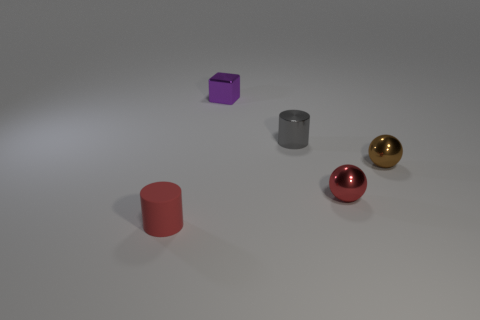Add 1 small gray shiny cylinders. How many objects exist? 6 Subtract all gray cylinders. How many cylinders are left? 1 Subtract all cylinders. How many objects are left? 3 Subtract 0 yellow balls. How many objects are left? 5 Subtract 2 spheres. How many spheres are left? 0 Subtract all brown spheres. Subtract all red blocks. How many spheres are left? 1 Subtract all cyan cubes. How many red cylinders are left? 1 Subtract all brown metallic things. Subtract all small cylinders. How many objects are left? 2 Add 1 tiny brown shiny spheres. How many tiny brown shiny spheres are left? 2 Add 2 yellow matte blocks. How many yellow matte blocks exist? 2 